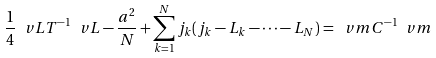<formula> <loc_0><loc_0><loc_500><loc_500>\frac { 1 } { 4 } \ v L T ^ { - 1 } \ v L - \frac { a ^ { 2 } } { N } + \sum _ { k = 1 } ^ { N } j _ { k } ( j _ { k } - L _ { k } - \cdots - L _ { N } ) = \ v m C ^ { - 1 } \ v m</formula> 